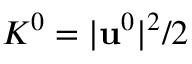<formula> <loc_0><loc_0><loc_500><loc_500>K ^ { 0 } = | \mathbf u ^ { 0 } | ^ { 2 } / 2</formula> 